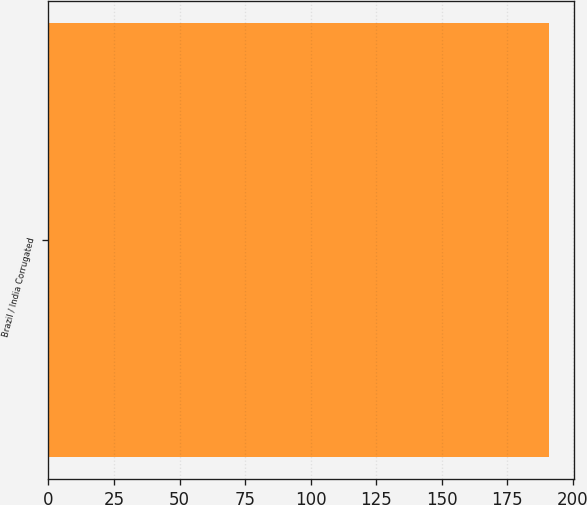<chart> <loc_0><loc_0><loc_500><loc_500><bar_chart><fcel>Brazil / India Corrugated<nl><fcel>190.83<nl></chart> 